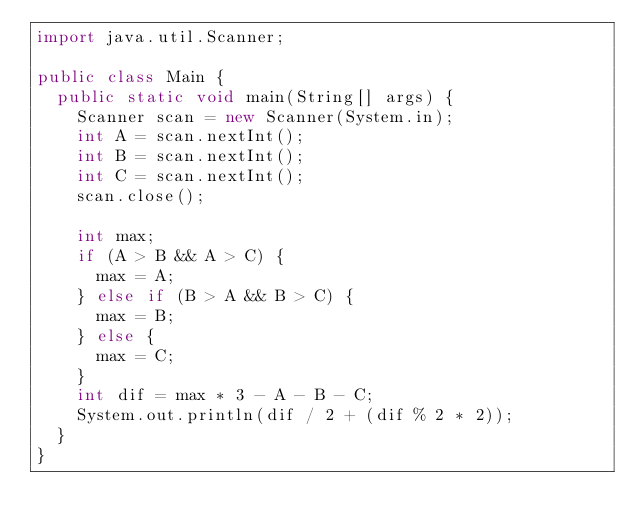<code> <loc_0><loc_0><loc_500><loc_500><_Java_>import java.util.Scanner;

public class Main {
	public static void main(String[] args) {
		Scanner scan = new Scanner(System.in);
		int A = scan.nextInt();
		int B = scan.nextInt();
		int C = scan.nextInt();
		scan.close();

		int max;
		if (A > B && A > C) {
			max = A;
		} else if (B > A && B > C) {
			max = B;
		} else {
			max = C;
		}
		int dif = max * 3 - A - B - C;
		System.out.println(dif / 2 + (dif % 2 * 2));
	}
}
</code> 